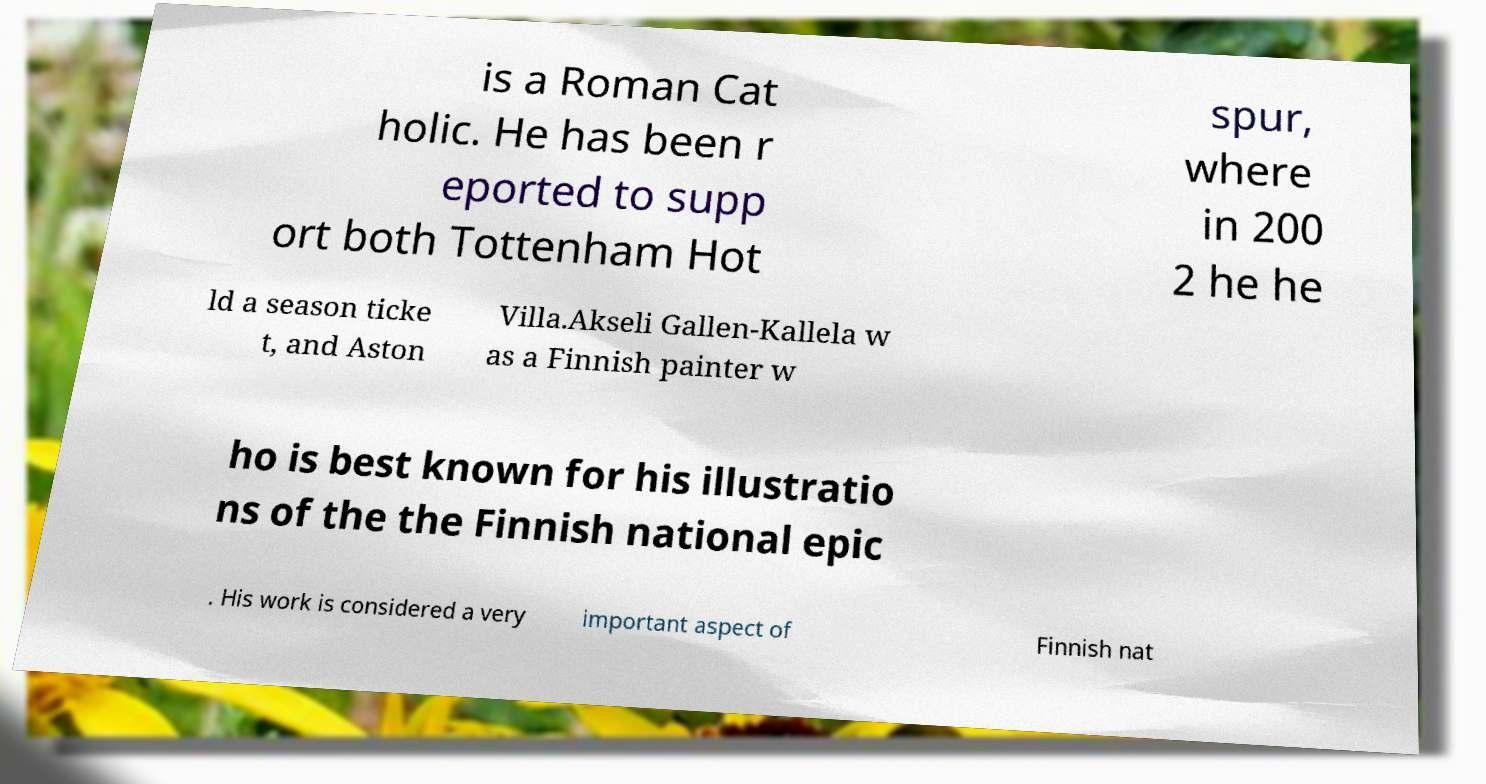Can you accurately transcribe the text from the provided image for me? is a Roman Cat holic. He has been r eported to supp ort both Tottenham Hot spur, where in 200 2 he he ld a season ticke t, and Aston Villa.Akseli Gallen-Kallela w as a Finnish painter w ho is best known for his illustratio ns of the the Finnish national epic . His work is considered a very important aspect of Finnish nat 